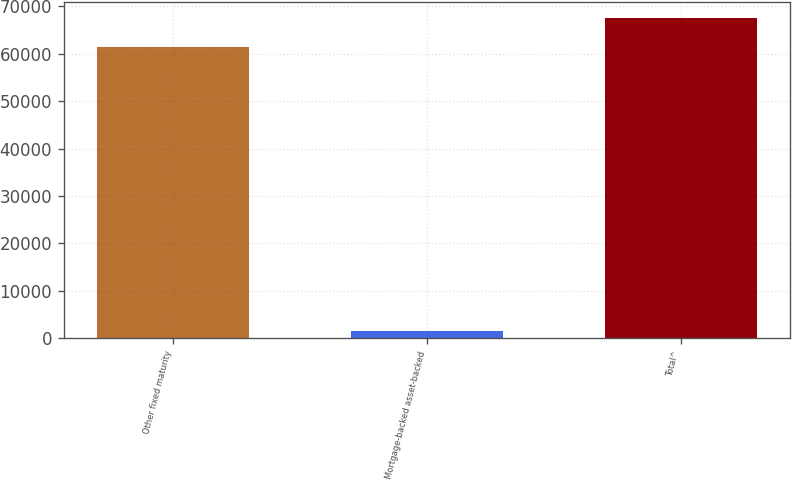Convert chart to OTSL. <chart><loc_0><loc_0><loc_500><loc_500><bar_chart><fcel>Other fixed maturity<fcel>Mortgage-backed asset-backed<fcel>Total^<nl><fcel>61428<fcel>1598<fcel>67570.8<nl></chart> 